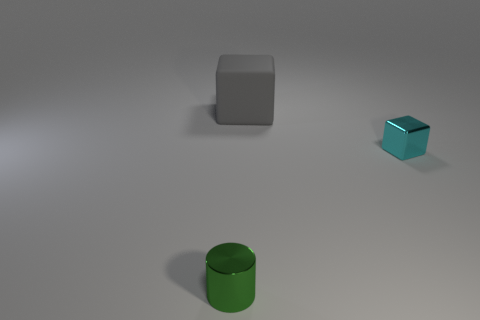Are there more gray objects that are behind the gray object than small cylinders that are in front of the tiny green cylinder?
Make the answer very short. No. Do the tiny cylinder and the object behind the cyan block have the same material?
Your answer should be compact. No. How many tiny cylinders are left of the thing behind the tiny thing that is on the right side of the shiny cylinder?
Your answer should be compact. 1. Does the gray matte thing have the same shape as the tiny shiny object on the right side of the cylinder?
Offer a very short reply. Yes. What is the color of the object that is both right of the small green thing and in front of the rubber block?
Offer a very short reply. Cyan. There is a block left of the small metallic thing right of the object that is left of the matte thing; what is it made of?
Make the answer very short. Rubber. What material is the green thing?
Your answer should be compact. Metal. There is another matte object that is the same shape as the small cyan thing; what is its size?
Offer a terse response. Large. What number of other things are made of the same material as the small cyan cube?
Provide a succinct answer. 1. Are there the same number of matte blocks that are in front of the small cyan block and big yellow rubber objects?
Offer a terse response. Yes. 